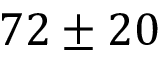<formula> <loc_0><loc_0><loc_500><loc_500>7 2 \pm 2 0</formula> 